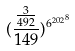Convert formula to latex. <formula><loc_0><loc_0><loc_500><loc_500>( \frac { \frac { 3 } { 4 9 2 } } { 1 4 9 } ) ^ { { 6 ^ { 2 0 2 } } ^ { 8 } }</formula> 